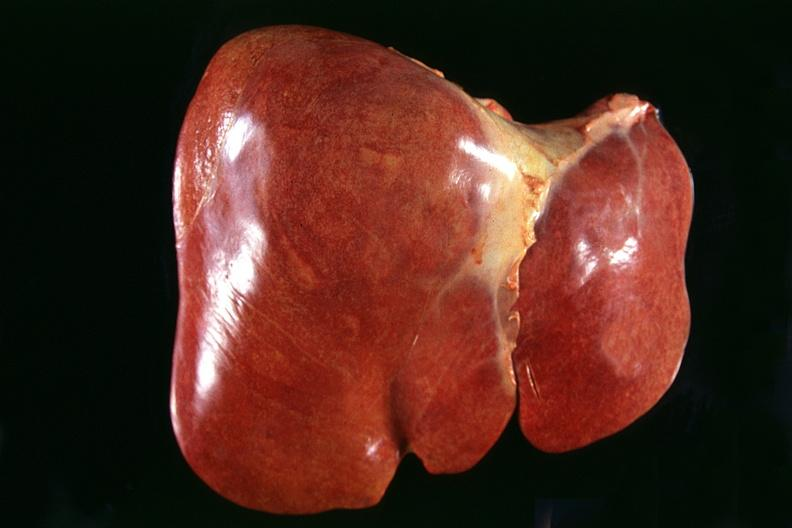what does this image show?
Answer the question using a single word or phrase. Normal liver 